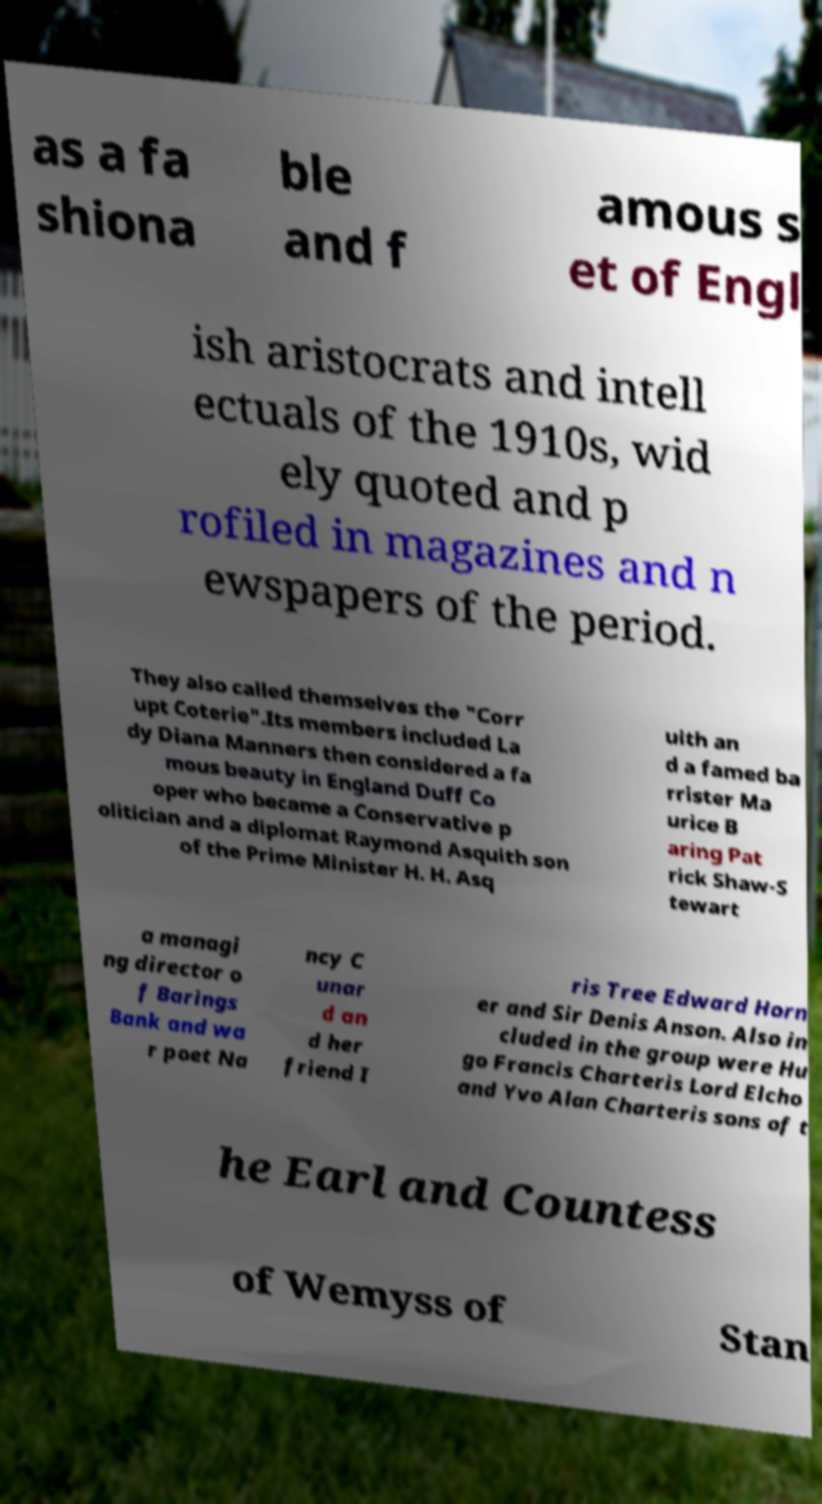Can you accurately transcribe the text from the provided image for me? as a fa shiona ble and f amous s et of Engl ish aristocrats and intell ectuals of the 1910s, wid ely quoted and p rofiled in magazines and n ewspapers of the period. They also called themselves the "Corr upt Coterie".Its members included La dy Diana Manners then considered a fa mous beauty in England Duff Co oper who became a Conservative p olitician and a diplomat Raymond Asquith son of the Prime Minister H. H. Asq uith an d a famed ba rrister Ma urice B aring Pat rick Shaw-S tewart a managi ng director o f Barings Bank and wa r poet Na ncy C unar d an d her friend I ris Tree Edward Horn er and Sir Denis Anson. Also in cluded in the group were Hu go Francis Charteris Lord Elcho and Yvo Alan Charteris sons of t he Earl and Countess of Wemyss of Stan 